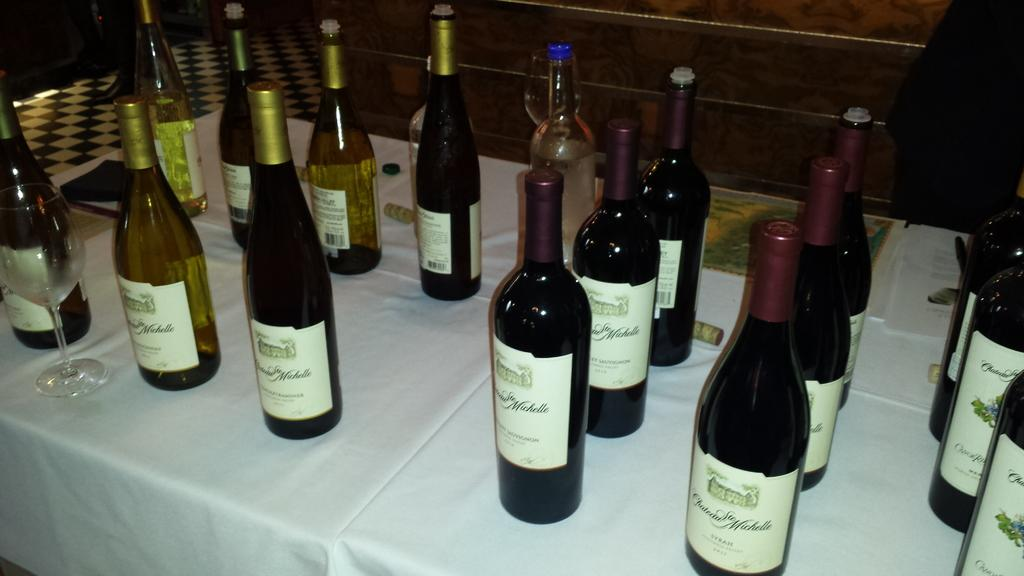What objects are grouped together in the image? There is a group of bottles in the image. What furniture is present on the table in the image? There are chairs on the table in the image. What can be seen in the background of the image? There is a wall and tiles in the background of the image. Where is the squirrel hiding in the image? There is no squirrel present in the image. 